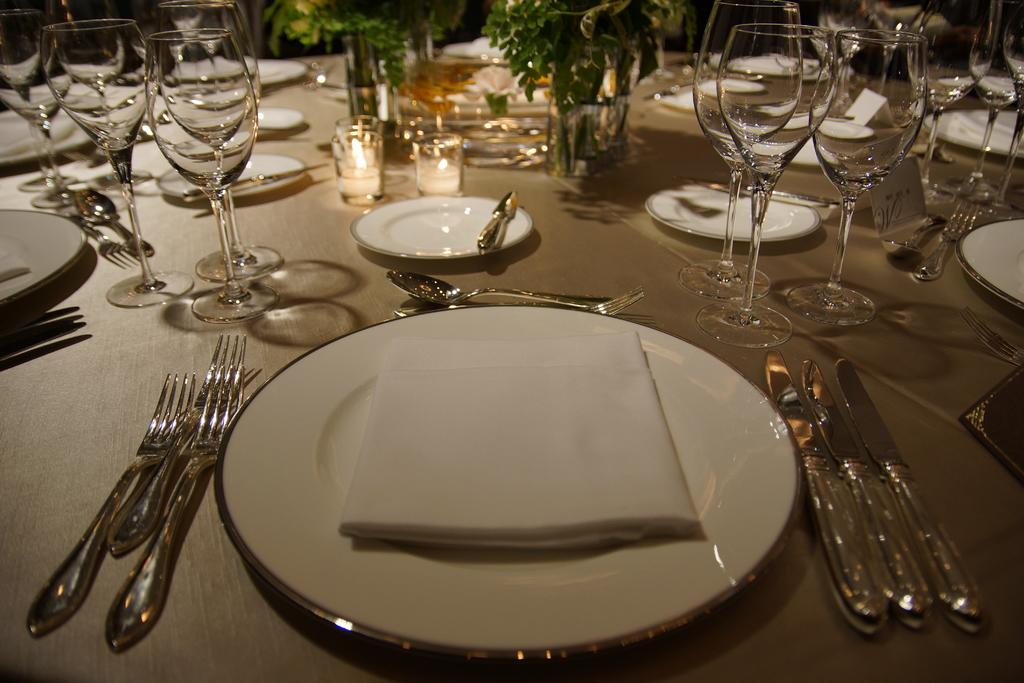What is the main piece of furniture in the image? There is a table in the image. What items can be seen on the table? There are glasses, plates, and spoons on the table. What is unique about the contents of the glasses? Small plants are visible in the glasses on the table. What type of wax can be seen melting in the image? There is no wax present in the image. How many boys are visible in the image? There are no boys visible in the image. 